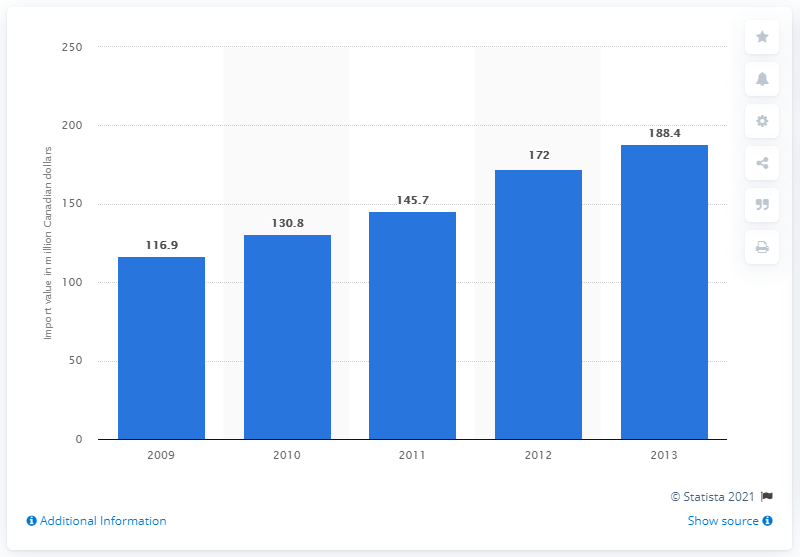List a handful of essential elements in this visual. In 2013, a total of 188,400 kilograms of chickpeas were imported to the 28 member states of the European Union, equivalent to a value of Canadian dollars. 